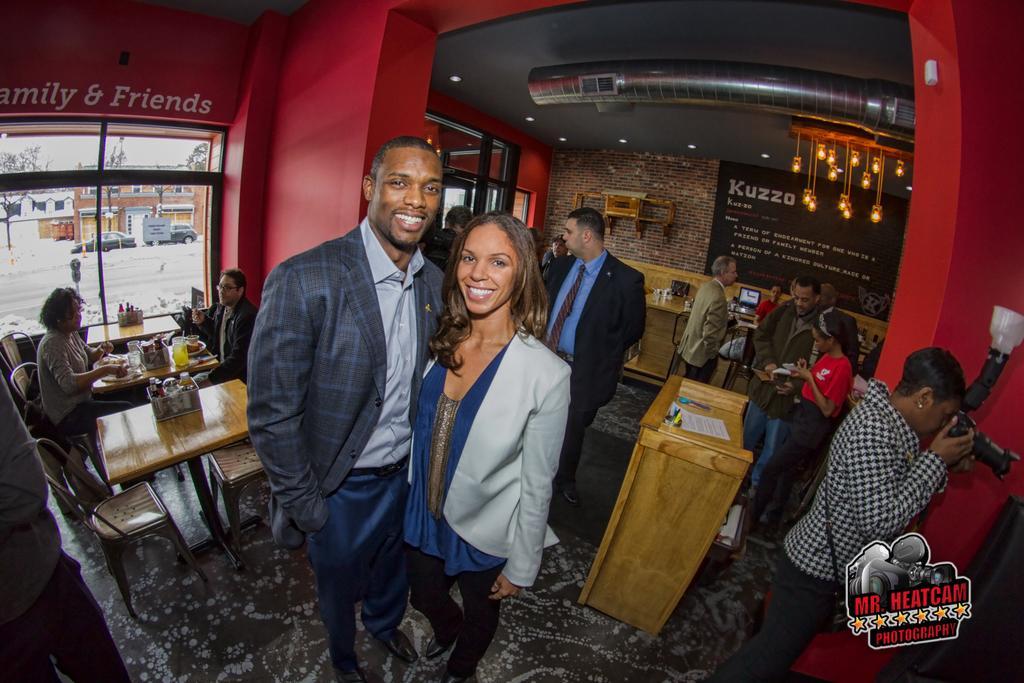Could you give a brief overview of what you see in this image? This image is clicked in a shop. There are lights on the top ,there are tables on the left and there are chairs on the left. People are sitting on chairs. There are two people standing one is man and other is woman in the middle of the image. The one who on the right side is clicking pictures with camera. There is a podium in the middle. On that podium there are some papers ,there are so many people near the podium there is a laptop behind those people there is window on the left side from that window we can see 2 cars and building over there. 